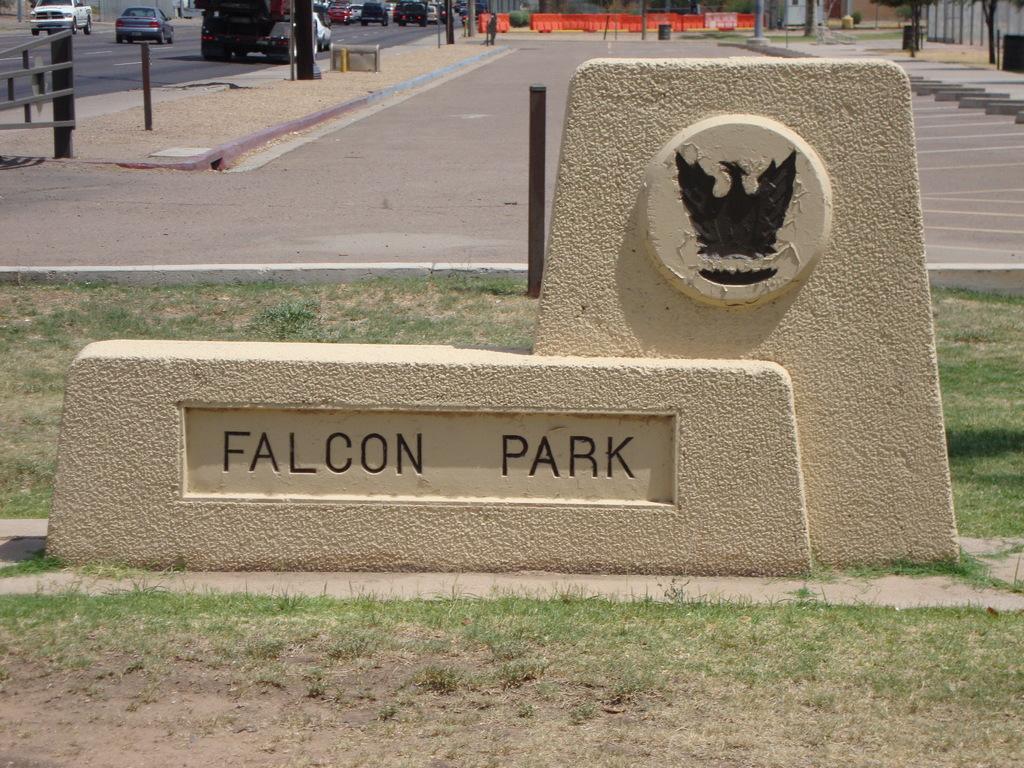Can you describe this image briefly? In this picture we can see some grass on the ground. We can see Falcon Park is written on the wall. There is a bird on this wall. Few vehicles are visible at the back. We can see few trees and some orange objects are seen in the background. 